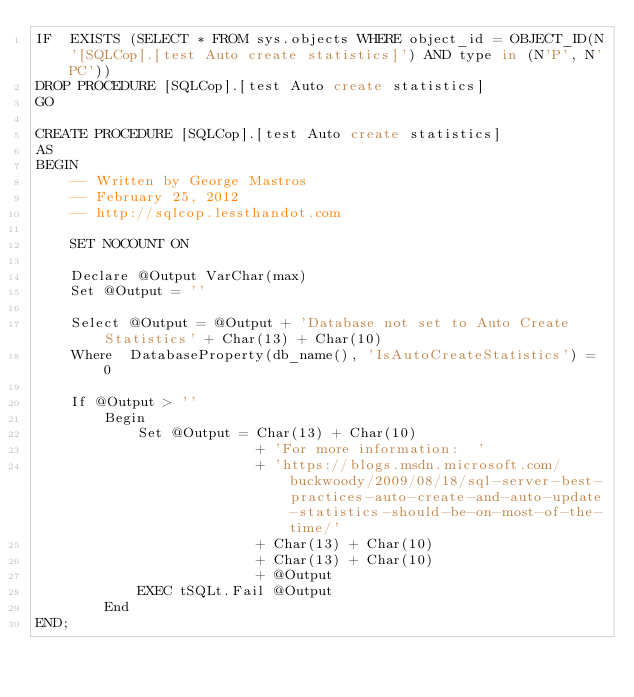Convert code to text. <code><loc_0><loc_0><loc_500><loc_500><_SQL_>IF  EXISTS (SELECT * FROM sys.objects WHERE object_id = OBJECT_ID(N'[SQLCop].[test Auto create statistics]') AND type in (N'P', N'PC'))
DROP PROCEDURE [SQLCop].[test Auto create statistics]
GO

CREATE PROCEDURE [SQLCop].[test Auto create statistics]
AS
BEGIN
	-- Written by George Mastros
	-- February 25, 2012
	-- http://sqlcop.lessthandot.com
	
	SET NOCOUNT ON
	
	Declare @Output VarChar(max)
	Set @Output = ''

    Select @Output = @Output + 'Database not set to Auto Create Statistics' + Char(13) + Char(10)
    Where  DatabaseProperty(db_name(), 'IsAutoCreateStatistics') = 0
    
	If @Output > '' 
		Begin
			Set @Output = Char(13) + Char(10) 
						  + 'For more information:  '
						  + 'https://blogs.msdn.microsoft.com/buckwoody/2009/08/18/sql-server-best-practices-auto-create-and-auto-update-statistics-should-be-on-most-of-the-time/'
						  + Char(13) + Char(10) 
						  + Char(13) + Char(10) 
						  + @Output
			EXEC tSQLt.Fail @Output
		End
END;</code> 